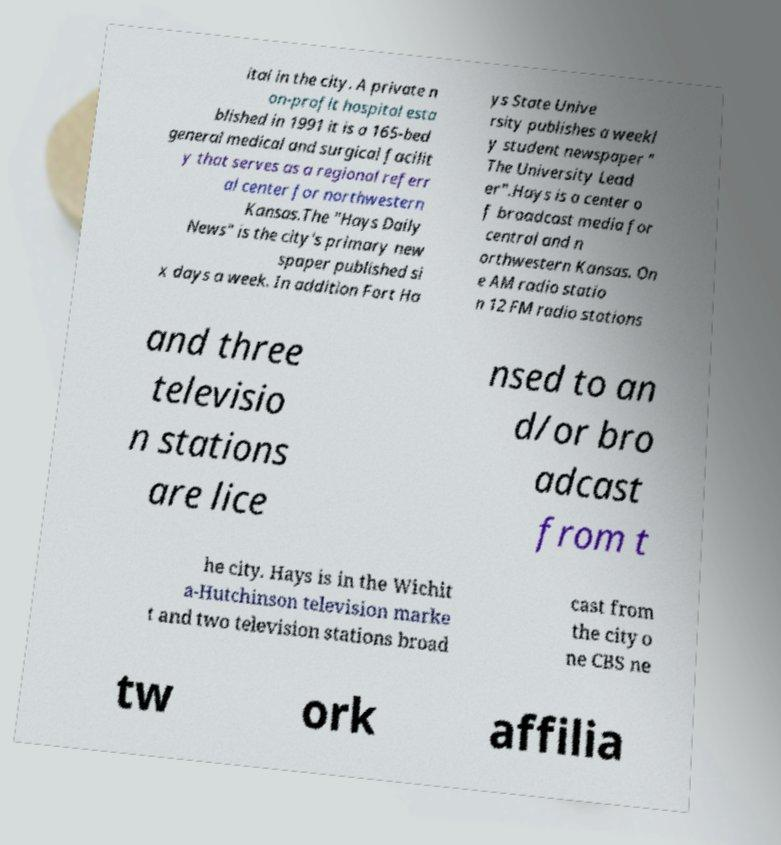For documentation purposes, I need the text within this image transcribed. Could you provide that? ital in the city. A private n on-profit hospital esta blished in 1991 it is a 165-bed general medical and surgical facilit y that serves as a regional referr al center for northwestern Kansas.The "Hays Daily News" is the city's primary new spaper published si x days a week. In addition Fort Ha ys State Unive rsity publishes a weekl y student newspaper " The University Lead er".Hays is a center o f broadcast media for central and n orthwestern Kansas. On e AM radio statio n 12 FM radio stations and three televisio n stations are lice nsed to an d/or bro adcast from t he city. Hays is in the Wichit a-Hutchinson television marke t and two television stations broad cast from the city o ne CBS ne tw ork affilia 